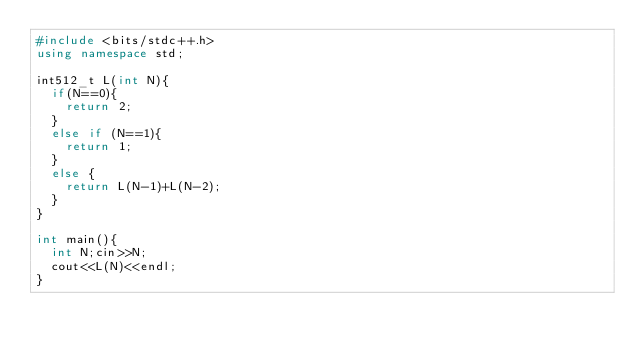Convert code to text. <code><loc_0><loc_0><loc_500><loc_500><_C++_>#include <bits/stdc++.h>
using namespace std;

int512_t L(int N){
  if(N==0){
    return 2;
  }
  else if (N==1){
    return 1;
  }
  else {
    return L(N-1)+L(N-2);
  }
}

int main(){
  int N;cin>>N;
  cout<<L(N)<<endl;
}
</code> 